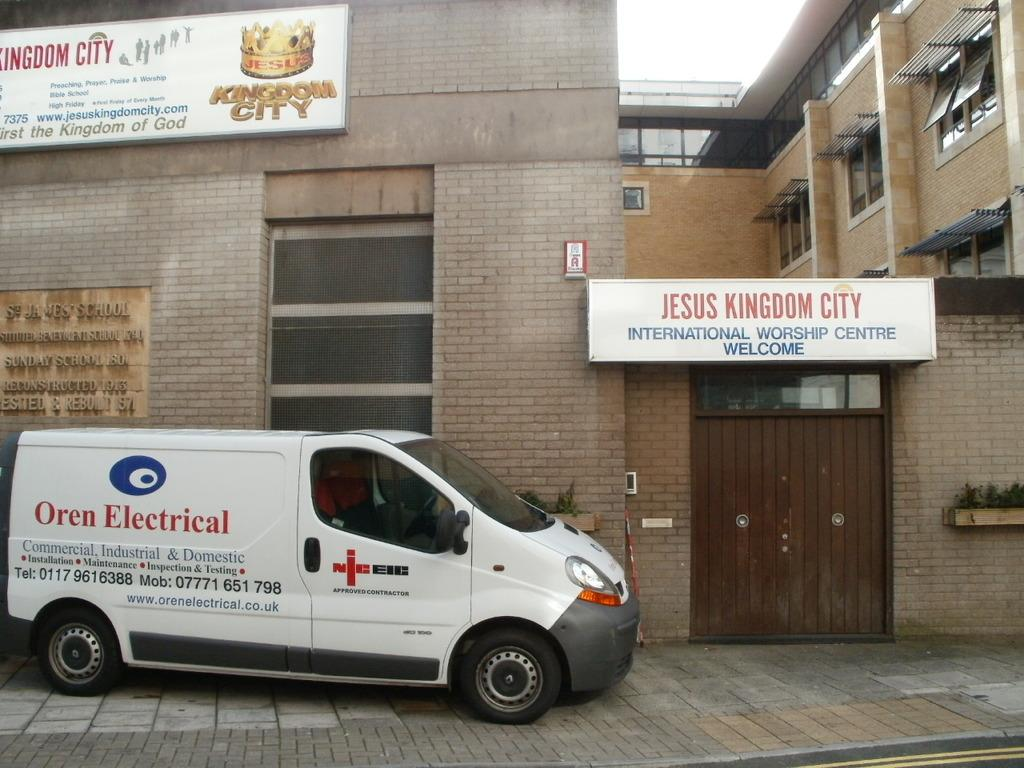<image>
Present a compact description of the photo's key features. A car for an electrical company is on the outside of a church. 